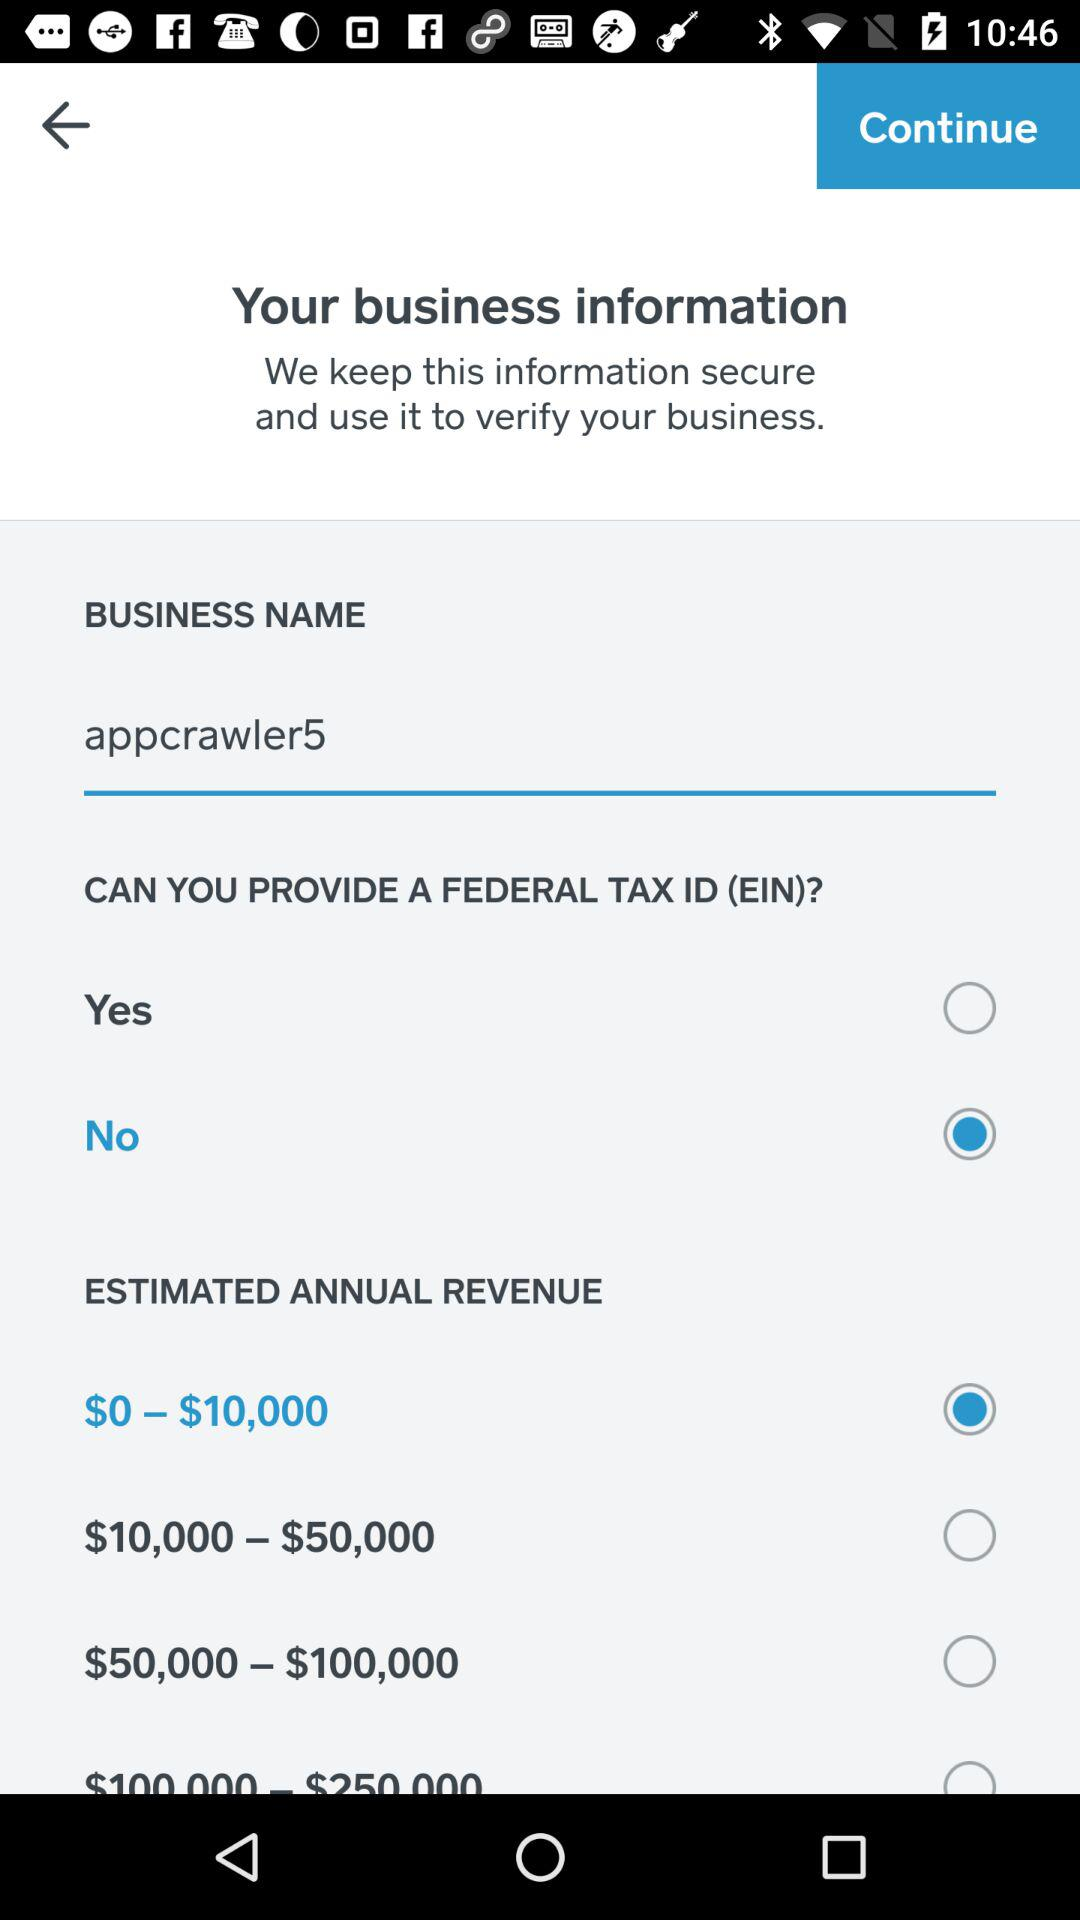What is the business name? The business name is "appcrawler5". 